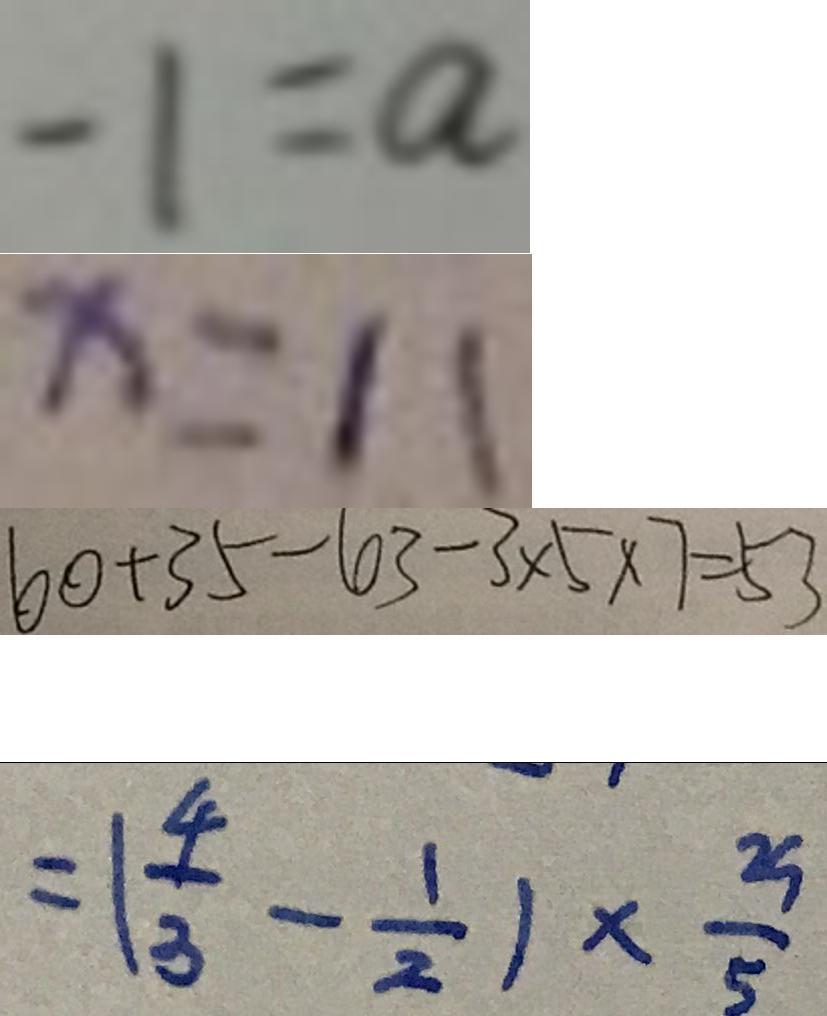<formula> <loc_0><loc_0><loc_500><loc_500>- 1 = a 
 x = 1 1 
 6 0 + 3 5 - 6 3 - 3 \times 5 \times 7 = 5 3 
 = ( \frac { 4 } { 3 } - \frac { 1 } { 2 } ) \times \frac { 2 9 } { 5 }</formula> 